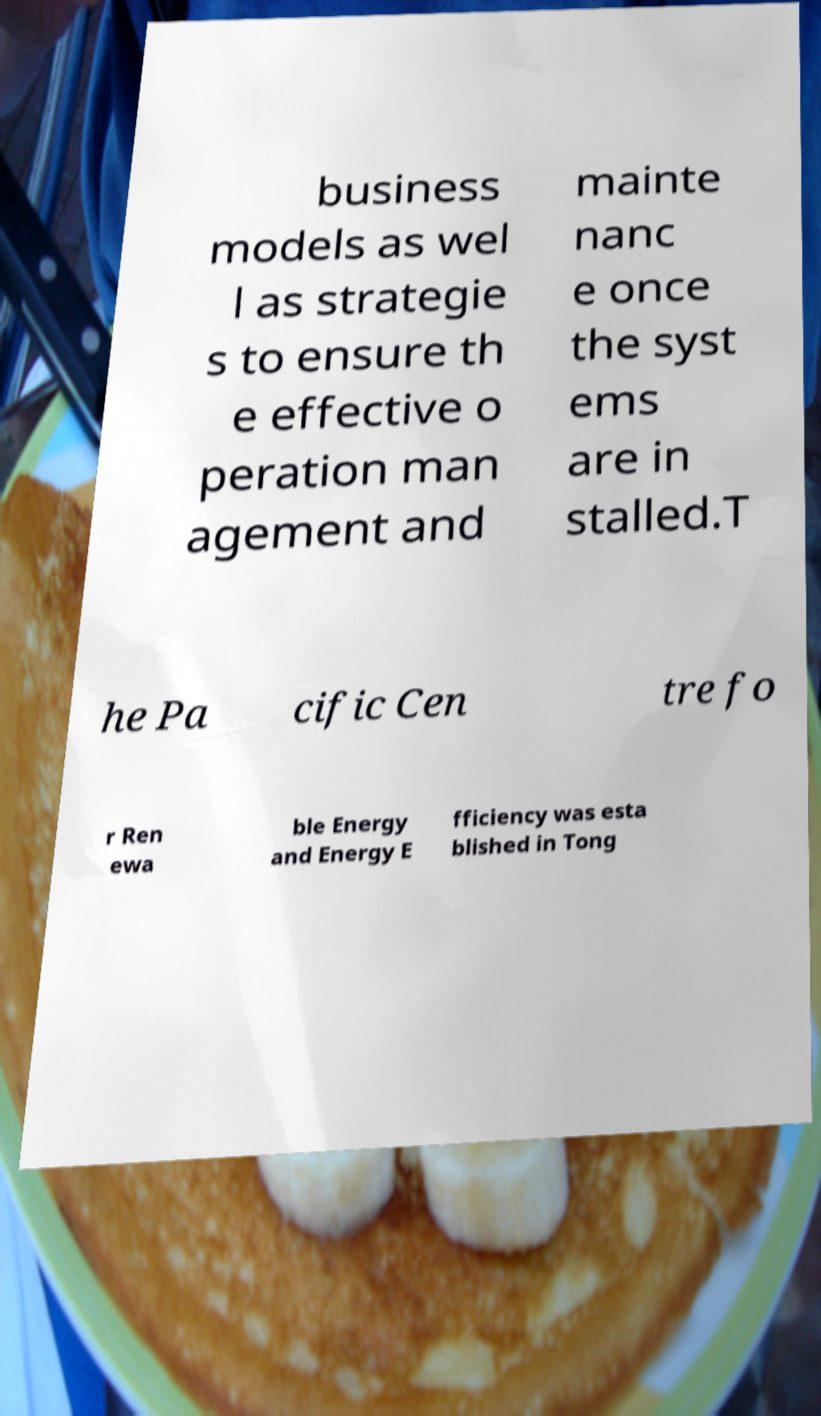Can you read and provide the text displayed in the image?This photo seems to have some interesting text. Can you extract and type it out for me? business models as wel l as strategie s to ensure th e effective o peration man agement and mainte nanc e once the syst ems are in stalled.T he Pa cific Cen tre fo r Ren ewa ble Energy and Energy E fficiency was esta blished in Tong 